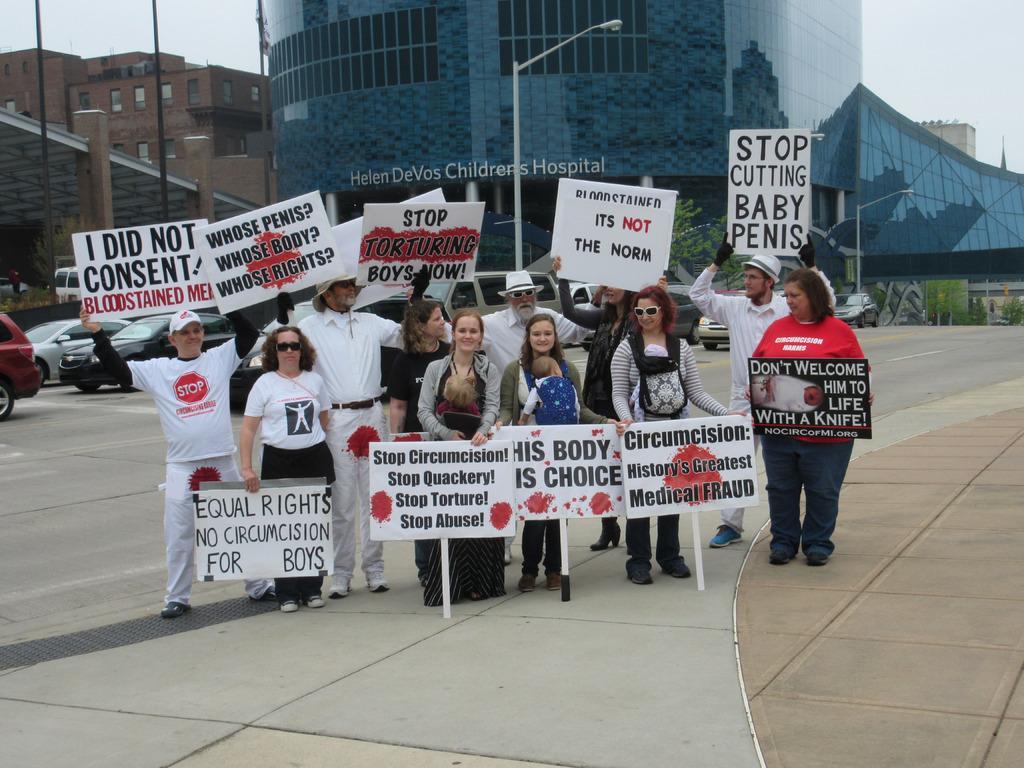In one or two sentences, can you explain what this image depicts? In this image, we can see a group of people are standing and holding boards. Here two women are carrying babies. Background we can see buildings, trees, poles, pillars, vehicles and sky. 